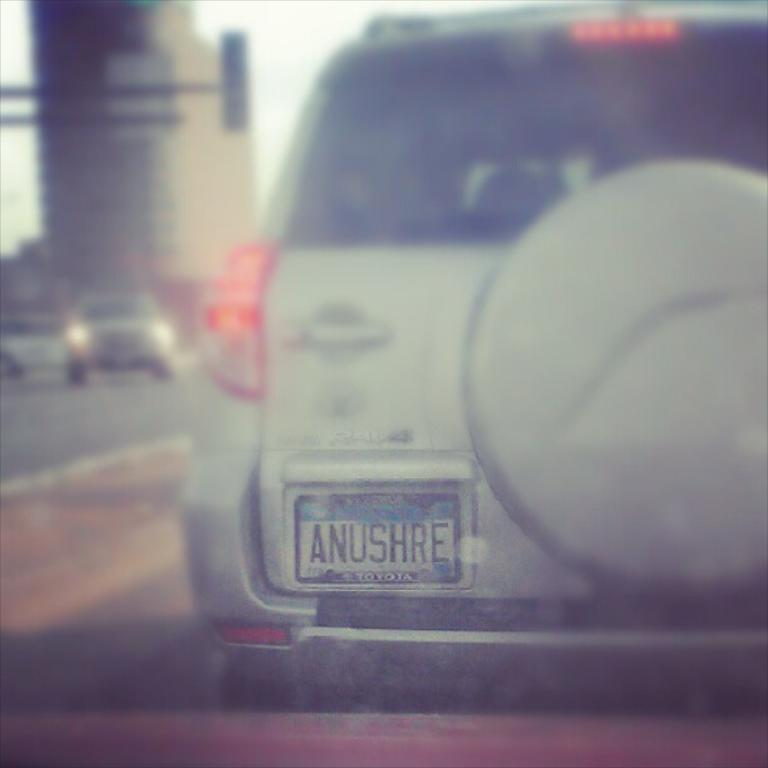<image>
Present a compact description of the photo's key features. The back side of a silver truck with the license plate reading anushre on it. 